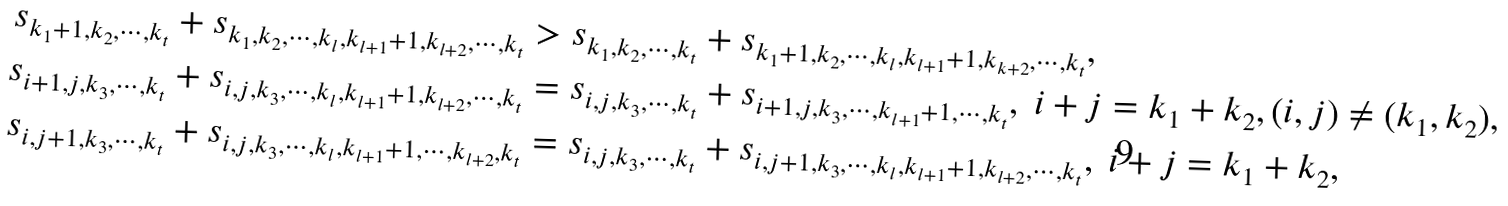Convert formula to latex. <formula><loc_0><loc_0><loc_500><loc_500>s _ { k _ { 1 } + 1 , k _ { 2 } , \cdots , k _ { t } } + s _ { k _ { 1 } , k _ { 2 } , \cdots , k _ { l } , k _ { l + 1 } + 1 , k _ { l + 2 } , \cdots , k _ { t } } & > s _ { k _ { 1 } , k _ { 2 } , \cdots , k _ { t } } + s _ { k _ { 1 } + 1 , k _ { 2 } , \cdots , k _ { l } , k _ { l + 1 } + 1 , k _ { k + 2 } , \cdots , k _ { t } } , \\ s _ { i + 1 , j , k _ { 3 } , \cdots , k _ { t } } + s _ { i , j , k _ { 3 } , \cdots , k _ { l } , k _ { l + 1 } + 1 , k _ { l + 2 } , \cdots , k _ { t } } & = s _ { i , j , k _ { 3 } , \cdots , k _ { t } } + s _ { i + 1 , j , k _ { 3 } , \cdots , k _ { l + 1 } + 1 , \cdots , k _ { t } } , \ i + j = k _ { 1 } + k _ { 2 } , ( i , j ) \neq ( k _ { 1 } , k _ { 2 } ) , \\ s _ { i , j + 1 , k _ { 3 } , \cdots , k _ { t } } + s _ { i , j , k _ { 3 } , \cdots , k _ { l } , k _ { l + 1 } + 1 , \cdots , k _ { l + 2 } , k _ { t } } & = s _ { i , j , k _ { 3 } , \cdots , k _ { t } } + s _ { i , j + 1 , k _ { 3 } , \cdots , k _ { l } , k _ { l + 1 } + 1 , k _ { l + 2 } , \cdots , k _ { t } } , \ i + j = k _ { 1 } + k _ { 2 } ,</formula> 